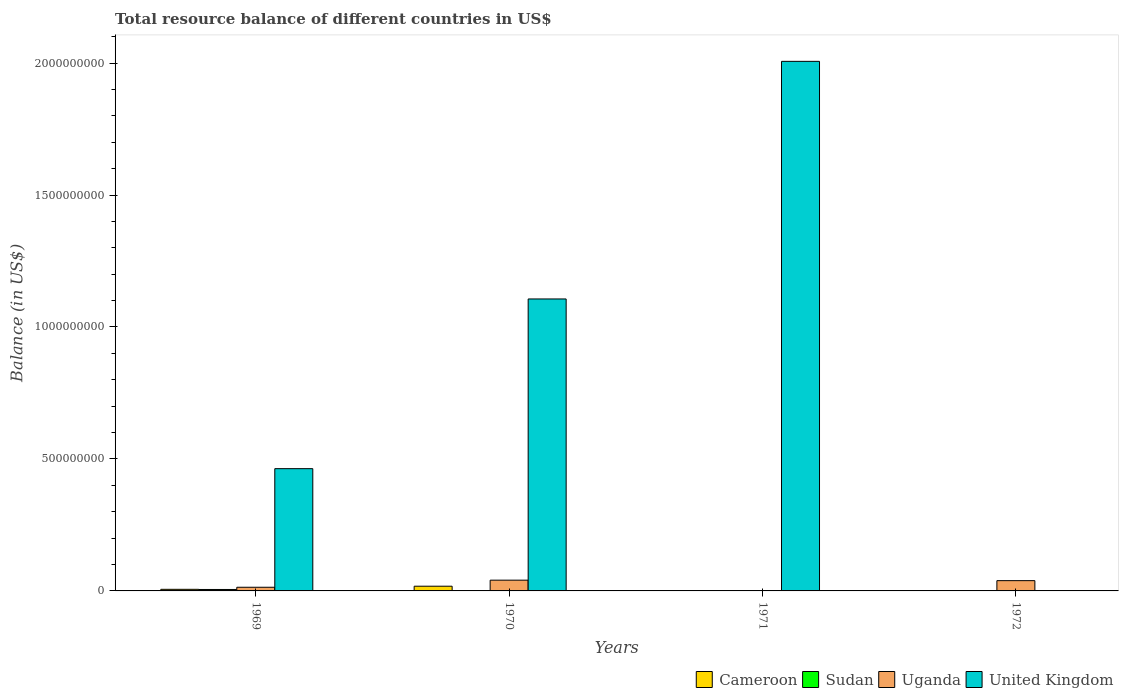Are the number of bars on each tick of the X-axis equal?
Offer a terse response. No. What is the label of the 2nd group of bars from the left?
Provide a short and direct response. 1970. In how many cases, is the number of bars for a given year not equal to the number of legend labels?
Offer a terse response. 3. Across all years, what is the maximum total resource balance in Sudan?
Ensure brevity in your answer.  5.46e+06. In which year was the total resource balance in Uganda maximum?
Provide a short and direct response. 1970. What is the total total resource balance in Sudan in the graph?
Make the answer very short. 5.46e+06. What is the difference between the total resource balance in Uganda in 1969 and that in 1972?
Provide a succinct answer. -2.51e+07. What is the difference between the total resource balance in Cameroon in 1972 and the total resource balance in Sudan in 1971?
Your answer should be very brief. 0. What is the average total resource balance in United Kingdom per year?
Provide a succinct answer. 8.94e+08. In the year 1969, what is the difference between the total resource balance in United Kingdom and total resource balance in Sudan?
Your answer should be compact. 4.58e+08. What is the difference between the highest and the second highest total resource balance in Uganda?
Offer a terse response. 1.82e+06. What is the difference between the highest and the lowest total resource balance in Uganda?
Make the answer very short. 4.07e+07. Is it the case that in every year, the sum of the total resource balance in United Kingdom and total resource balance in Sudan is greater than the total resource balance in Cameroon?
Your answer should be very brief. No. Are all the bars in the graph horizontal?
Your response must be concise. No. How many years are there in the graph?
Your answer should be very brief. 4. What is the difference between two consecutive major ticks on the Y-axis?
Give a very brief answer. 5.00e+08. Does the graph contain any zero values?
Offer a very short reply. Yes. Does the graph contain grids?
Give a very brief answer. No. Where does the legend appear in the graph?
Make the answer very short. Bottom right. How are the legend labels stacked?
Offer a very short reply. Horizontal. What is the title of the graph?
Provide a succinct answer. Total resource balance of different countries in US$. Does "Algeria" appear as one of the legend labels in the graph?
Your answer should be very brief. No. What is the label or title of the Y-axis?
Make the answer very short. Balance (in US$). What is the Balance (in US$) in Cameroon in 1969?
Keep it short and to the point. 6.04e+06. What is the Balance (in US$) in Sudan in 1969?
Make the answer very short. 5.46e+06. What is the Balance (in US$) in Uganda in 1969?
Offer a very short reply. 1.39e+07. What is the Balance (in US$) in United Kingdom in 1969?
Provide a succinct answer. 4.63e+08. What is the Balance (in US$) in Cameroon in 1970?
Offer a terse response. 1.79e+07. What is the Balance (in US$) of Uganda in 1970?
Provide a short and direct response. 4.07e+07. What is the Balance (in US$) of United Kingdom in 1970?
Your answer should be very brief. 1.11e+09. What is the Balance (in US$) of Cameroon in 1971?
Your response must be concise. 0. What is the Balance (in US$) of Sudan in 1971?
Provide a short and direct response. 0. What is the Balance (in US$) of United Kingdom in 1971?
Ensure brevity in your answer.  2.01e+09. What is the Balance (in US$) of Sudan in 1972?
Ensure brevity in your answer.  0. What is the Balance (in US$) in Uganda in 1972?
Your response must be concise. 3.89e+07. Across all years, what is the maximum Balance (in US$) of Cameroon?
Make the answer very short. 1.79e+07. Across all years, what is the maximum Balance (in US$) in Sudan?
Your answer should be very brief. 5.46e+06. Across all years, what is the maximum Balance (in US$) in Uganda?
Make the answer very short. 4.07e+07. Across all years, what is the maximum Balance (in US$) in United Kingdom?
Provide a succinct answer. 2.01e+09. Across all years, what is the minimum Balance (in US$) of Cameroon?
Provide a short and direct response. 0. What is the total Balance (in US$) of Cameroon in the graph?
Provide a succinct answer. 2.39e+07. What is the total Balance (in US$) of Sudan in the graph?
Offer a terse response. 5.46e+06. What is the total Balance (in US$) in Uganda in the graph?
Provide a succinct answer. 9.35e+07. What is the total Balance (in US$) of United Kingdom in the graph?
Make the answer very short. 3.58e+09. What is the difference between the Balance (in US$) in Cameroon in 1969 and that in 1970?
Provide a short and direct response. -1.18e+07. What is the difference between the Balance (in US$) of Uganda in 1969 and that in 1970?
Offer a terse response. -2.69e+07. What is the difference between the Balance (in US$) in United Kingdom in 1969 and that in 1970?
Keep it short and to the point. -6.43e+08. What is the difference between the Balance (in US$) in United Kingdom in 1969 and that in 1971?
Your response must be concise. -1.54e+09. What is the difference between the Balance (in US$) in Uganda in 1969 and that in 1972?
Provide a short and direct response. -2.51e+07. What is the difference between the Balance (in US$) of United Kingdom in 1970 and that in 1971?
Your response must be concise. -9.00e+08. What is the difference between the Balance (in US$) in Uganda in 1970 and that in 1972?
Give a very brief answer. 1.82e+06. What is the difference between the Balance (in US$) in Cameroon in 1969 and the Balance (in US$) in Uganda in 1970?
Your response must be concise. -3.47e+07. What is the difference between the Balance (in US$) of Cameroon in 1969 and the Balance (in US$) of United Kingdom in 1970?
Offer a terse response. -1.10e+09. What is the difference between the Balance (in US$) in Sudan in 1969 and the Balance (in US$) in Uganda in 1970?
Ensure brevity in your answer.  -3.53e+07. What is the difference between the Balance (in US$) of Sudan in 1969 and the Balance (in US$) of United Kingdom in 1970?
Offer a very short reply. -1.10e+09. What is the difference between the Balance (in US$) of Uganda in 1969 and the Balance (in US$) of United Kingdom in 1970?
Keep it short and to the point. -1.09e+09. What is the difference between the Balance (in US$) of Cameroon in 1969 and the Balance (in US$) of United Kingdom in 1971?
Provide a short and direct response. -2.00e+09. What is the difference between the Balance (in US$) of Sudan in 1969 and the Balance (in US$) of United Kingdom in 1971?
Give a very brief answer. -2.00e+09. What is the difference between the Balance (in US$) of Uganda in 1969 and the Balance (in US$) of United Kingdom in 1971?
Provide a short and direct response. -1.99e+09. What is the difference between the Balance (in US$) of Cameroon in 1969 and the Balance (in US$) of Uganda in 1972?
Keep it short and to the point. -3.29e+07. What is the difference between the Balance (in US$) of Sudan in 1969 and the Balance (in US$) of Uganda in 1972?
Your answer should be very brief. -3.35e+07. What is the difference between the Balance (in US$) of Cameroon in 1970 and the Balance (in US$) of United Kingdom in 1971?
Give a very brief answer. -1.99e+09. What is the difference between the Balance (in US$) in Uganda in 1970 and the Balance (in US$) in United Kingdom in 1971?
Give a very brief answer. -1.97e+09. What is the difference between the Balance (in US$) of Cameroon in 1970 and the Balance (in US$) of Uganda in 1972?
Provide a succinct answer. -2.11e+07. What is the average Balance (in US$) of Cameroon per year?
Your answer should be compact. 5.98e+06. What is the average Balance (in US$) in Sudan per year?
Your answer should be very brief. 1.36e+06. What is the average Balance (in US$) in Uganda per year?
Give a very brief answer. 2.34e+07. What is the average Balance (in US$) in United Kingdom per year?
Offer a terse response. 8.94e+08. In the year 1969, what is the difference between the Balance (in US$) of Cameroon and Balance (in US$) of Sudan?
Your answer should be compact. 5.85e+05. In the year 1969, what is the difference between the Balance (in US$) of Cameroon and Balance (in US$) of Uganda?
Keep it short and to the point. -7.82e+06. In the year 1969, what is the difference between the Balance (in US$) in Cameroon and Balance (in US$) in United Kingdom?
Offer a very short reply. -4.57e+08. In the year 1969, what is the difference between the Balance (in US$) of Sudan and Balance (in US$) of Uganda?
Provide a short and direct response. -8.40e+06. In the year 1969, what is the difference between the Balance (in US$) of Sudan and Balance (in US$) of United Kingdom?
Provide a short and direct response. -4.58e+08. In the year 1969, what is the difference between the Balance (in US$) of Uganda and Balance (in US$) of United Kingdom?
Give a very brief answer. -4.49e+08. In the year 1970, what is the difference between the Balance (in US$) in Cameroon and Balance (in US$) in Uganda?
Make the answer very short. -2.29e+07. In the year 1970, what is the difference between the Balance (in US$) in Cameroon and Balance (in US$) in United Kingdom?
Your answer should be very brief. -1.09e+09. In the year 1970, what is the difference between the Balance (in US$) of Uganda and Balance (in US$) of United Kingdom?
Give a very brief answer. -1.07e+09. What is the ratio of the Balance (in US$) of Cameroon in 1969 to that in 1970?
Make the answer very short. 0.34. What is the ratio of the Balance (in US$) in Uganda in 1969 to that in 1970?
Ensure brevity in your answer.  0.34. What is the ratio of the Balance (in US$) of United Kingdom in 1969 to that in 1970?
Offer a very short reply. 0.42. What is the ratio of the Balance (in US$) of United Kingdom in 1969 to that in 1971?
Offer a very short reply. 0.23. What is the ratio of the Balance (in US$) in Uganda in 1969 to that in 1972?
Make the answer very short. 0.36. What is the ratio of the Balance (in US$) in United Kingdom in 1970 to that in 1971?
Provide a short and direct response. 0.55. What is the ratio of the Balance (in US$) in Uganda in 1970 to that in 1972?
Offer a terse response. 1.05. What is the difference between the highest and the second highest Balance (in US$) of Uganda?
Give a very brief answer. 1.82e+06. What is the difference between the highest and the second highest Balance (in US$) of United Kingdom?
Make the answer very short. 9.00e+08. What is the difference between the highest and the lowest Balance (in US$) of Cameroon?
Ensure brevity in your answer.  1.79e+07. What is the difference between the highest and the lowest Balance (in US$) in Sudan?
Your answer should be very brief. 5.46e+06. What is the difference between the highest and the lowest Balance (in US$) in Uganda?
Provide a short and direct response. 4.07e+07. What is the difference between the highest and the lowest Balance (in US$) of United Kingdom?
Provide a short and direct response. 2.01e+09. 